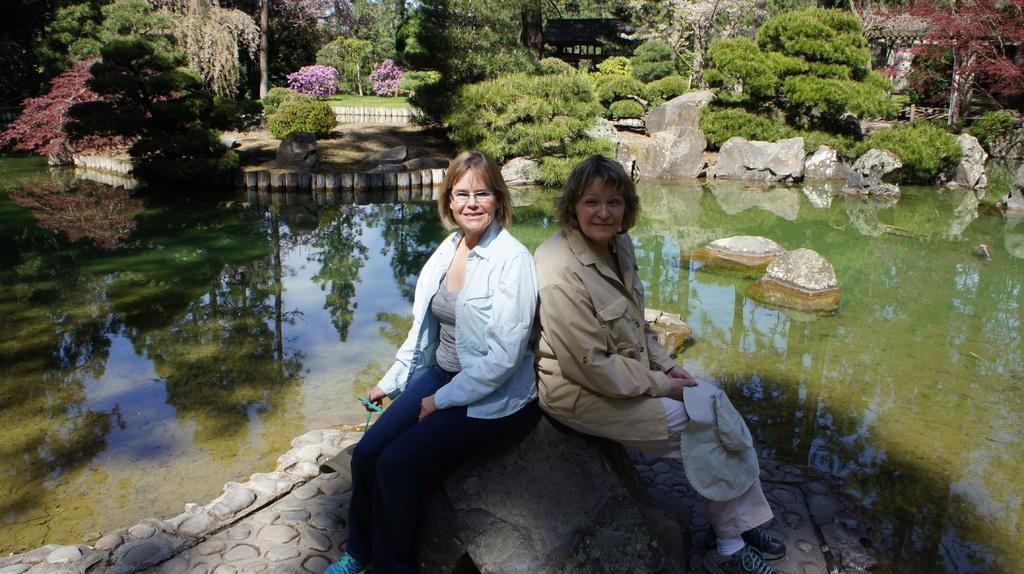Could you give a brief overview of what you see in this image? There are two women sitting and smiling. Here is the water. I can see the rocks. These are the trees and bushes. These water look green in color. 